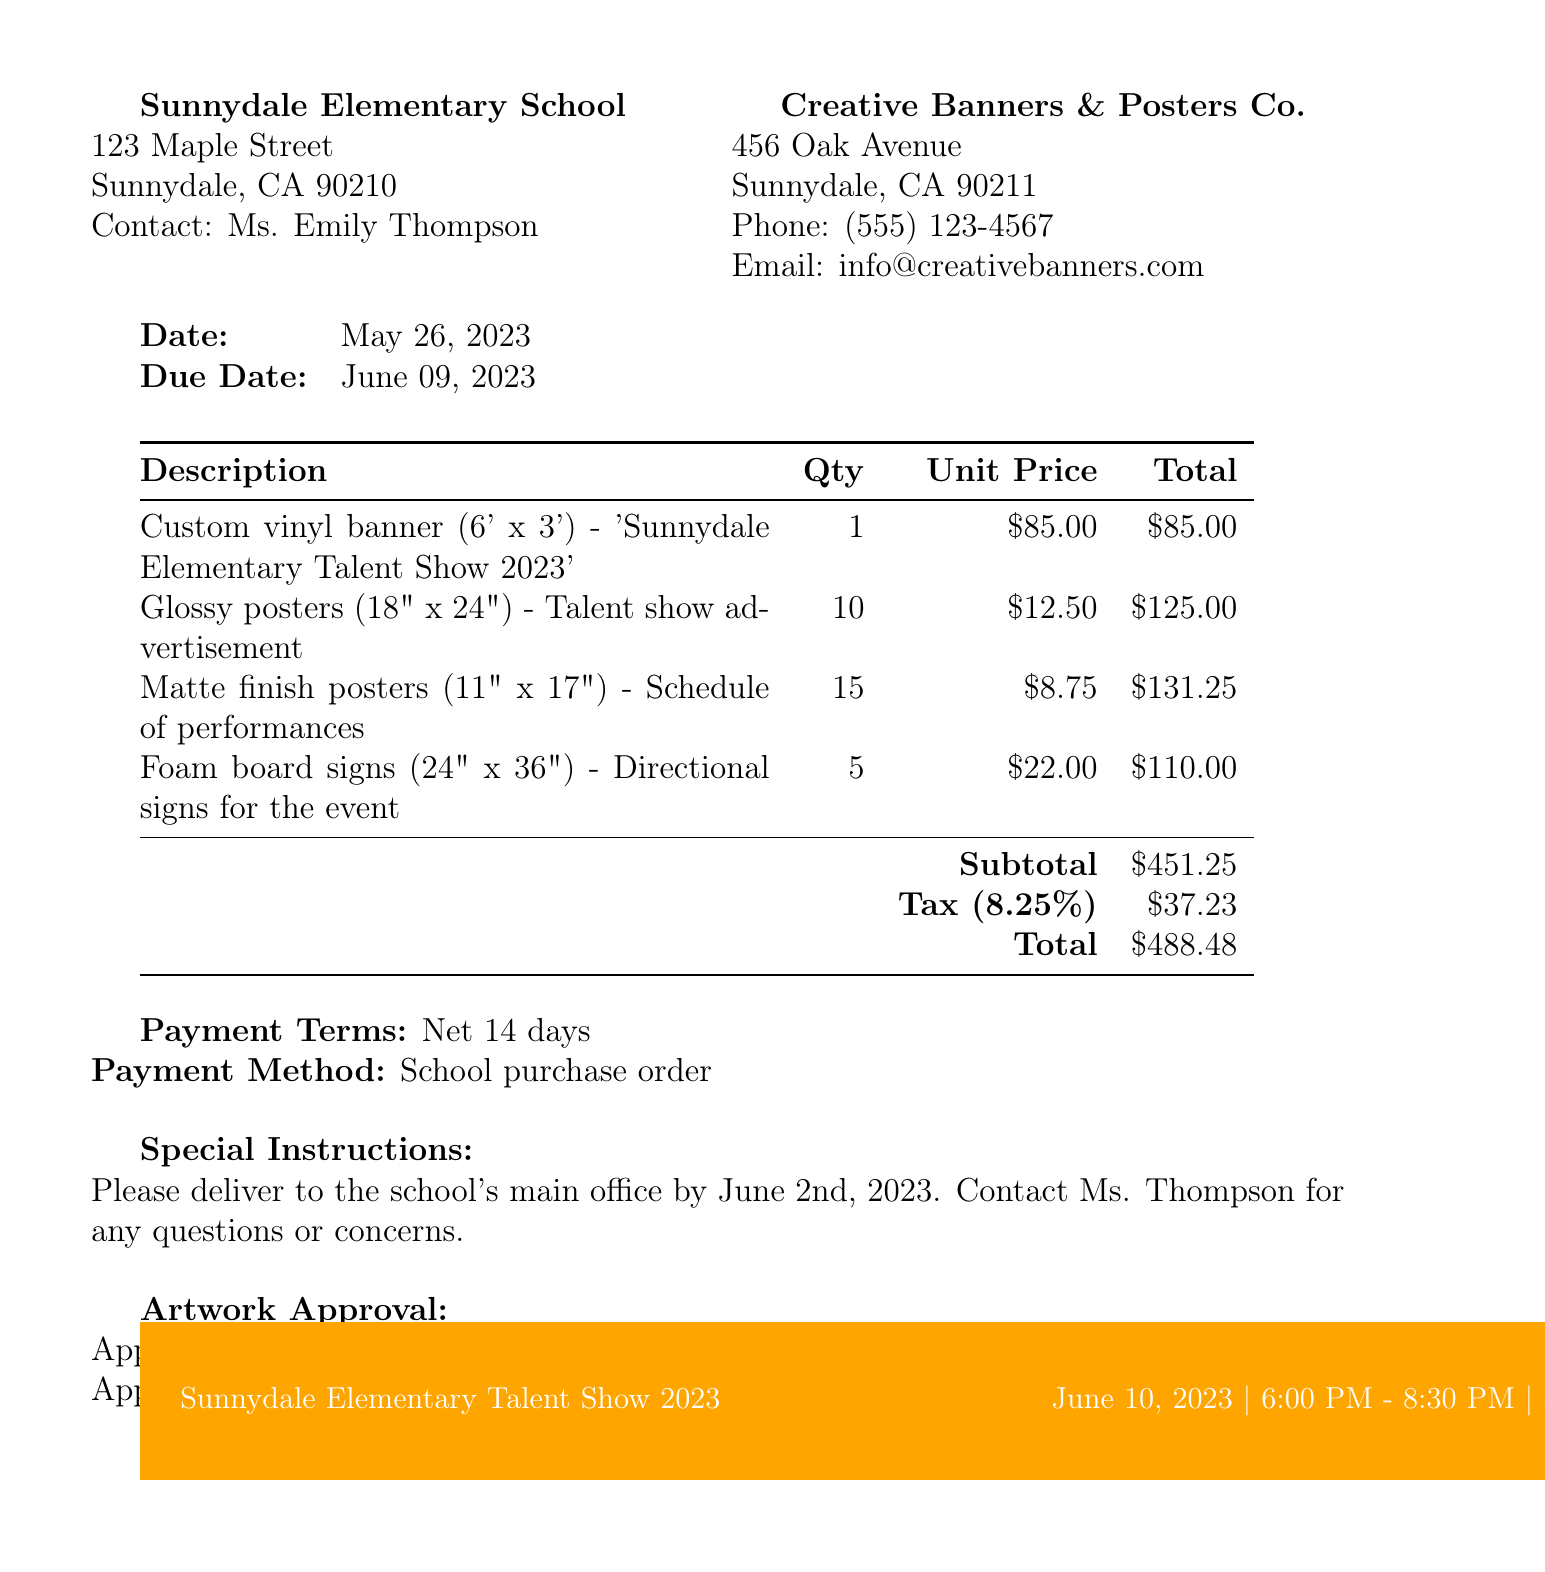What is the invoice number? The invoice number is listed in the document, which is INV-2023-0526.
Answer: INV-2023-0526 What is the due date for payment? The due date is mentioned in the invoice details as June 09, 2023.
Answer: June 09, 2023 How many glossy posters were ordered? The quantity for glossy posters can be found in the items list, which states 10.
Answer: 10 What is the total amount due? The total amount is specified at the end of the invoice, which is $488.48.
Answer: $488.48 Who is the contact person at the school? The contact person at Sunnydale Elementary School is mentioned as Ms. Emily Thompson.
Answer: Ms. Emily Thompson What is the tax rate applied? The tax rate is given in the additional information as 8.25%.
Answer: 8.25% When was the artwork approved? The artwork approval date is specified as May 22, 2023.
Answer: May 22, 2023 What is the payment method? The payment method is stated as "School purchase order" in the additional information section.
Answer: School purchase order What is the venue for the talent show? The venue for the event is listed as the School Auditorium.
Answer: School Auditorium 